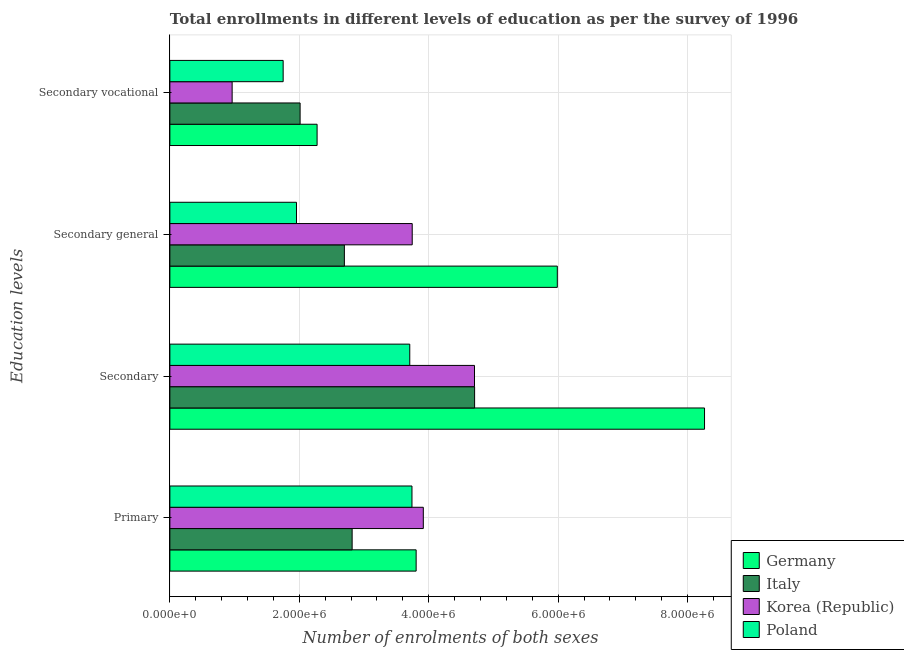How many groups of bars are there?
Make the answer very short. 4. Are the number of bars per tick equal to the number of legend labels?
Provide a succinct answer. Yes. Are the number of bars on each tick of the Y-axis equal?
Ensure brevity in your answer.  Yes. What is the label of the 3rd group of bars from the top?
Offer a very short reply. Secondary. What is the number of enrolments in secondary general education in Poland?
Your response must be concise. 1.96e+06. Across all countries, what is the maximum number of enrolments in secondary general education?
Give a very brief answer. 5.99e+06. Across all countries, what is the minimum number of enrolments in secondary general education?
Make the answer very short. 1.96e+06. In which country was the number of enrolments in secondary vocational education maximum?
Your response must be concise. Germany. What is the total number of enrolments in secondary vocational education in the graph?
Your answer should be very brief. 7.00e+06. What is the difference between the number of enrolments in secondary general education in Korea (Republic) and that in Poland?
Make the answer very short. 1.79e+06. What is the difference between the number of enrolments in primary education in Poland and the number of enrolments in secondary general education in Germany?
Provide a short and direct response. -2.25e+06. What is the average number of enrolments in secondary general education per country?
Offer a terse response. 3.60e+06. What is the difference between the number of enrolments in secondary education and number of enrolments in secondary vocational education in Poland?
Ensure brevity in your answer.  1.96e+06. What is the ratio of the number of enrolments in secondary general education in Korea (Republic) to that in Poland?
Provide a succinct answer. 1.91. Is the number of enrolments in primary education in Germany less than that in Poland?
Your answer should be compact. No. Is the difference between the number of enrolments in secondary general education in Korea (Republic) and Germany greater than the difference between the number of enrolments in secondary education in Korea (Republic) and Germany?
Offer a terse response. Yes. What is the difference between the highest and the second highest number of enrolments in secondary education?
Give a very brief answer. 3.55e+06. What is the difference between the highest and the lowest number of enrolments in secondary education?
Provide a short and direct response. 4.55e+06. In how many countries, is the number of enrolments in secondary education greater than the average number of enrolments in secondary education taken over all countries?
Offer a terse response. 1. Is the sum of the number of enrolments in primary education in Italy and Poland greater than the maximum number of enrolments in secondary vocational education across all countries?
Offer a terse response. Yes. What does the 1st bar from the top in Secondary general represents?
Give a very brief answer. Poland. What does the 4th bar from the bottom in Primary represents?
Offer a very short reply. Poland. Are the values on the major ticks of X-axis written in scientific E-notation?
Give a very brief answer. Yes. Does the graph contain any zero values?
Your answer should be compact. No. Where does the legend appear in the graph?
Provide a succinct answer. Bottom right. How many legend labels are there?
Provide a short and direct response. 4. How are the legend labels stacked?
Your answer should be compact. Vertical. What is the title of the graph?
Provide a short and direct response. Total enrollments in different levels of education as per the survey of 1996. Does "New Zealand" appear as one of the legend labels in the graph?
Make the answer very short. No. What is the label or title of the X-axis?
Make the answer very short. Number of enrolments of both sexes. What is the label or title of the Y-axis?
Give a very brief answer. Education levels. What is the Number of enrolments of both sexes in Germany in Primary?
Make the answer very short. 3.80e+06. What is the Number of enrolments of both sexes of Italy in Primary?
Give a very brief answer. 2.82e+06. What is the Number of enrolments of both sexes of Korea (Republic) in Primary?
Provide a succinct answer. 3.92e+06. What is the Number of enrolments of both sexes of Poland in Primary?
Offer a very short reply. 3.74e+06. What is the Number of enrolments of both sexes in Germany in Secondary?
Provide a short and direct response. 8.26e+06. What is the Number of enrolments of both sexes of Italy in Secondary?
Keep it short and to the point. 4.71e+06. What is the Number of enrolments of both sexes of Korea (Republic) in Secondary?
Ensure brevity in your answer.  4.71e+06. What is the Number of enrolments of both sexes of Poland in Secondary?
Your answer should be compact. 3.71e+06. What is the Number of enrolments of both sexes of Germany in Secondary general?
Your response must be concise. 5.99e+06. What is the Number of enrolments of both sexes of Italy in Secondary general?
Make the answer very short. 2.70e+06. What is the Number of enrolments of both sexes in Korea (Republic) in Secondary general?
Keep it short and to the point. 3.74e+06. What is the Number of enrolments of both sexes of Poland in Secondary general?
Your response must be concise. 1.96e+06. What is the Number of enrolments of both sexes in Germany in Secondary vocational?
Provide a succinct answer. 2.27e+06. What is the Number of enrolments of both sexes in Italy in Secondary vocational?
Provide a short and direct response. 2.01e+06. What is the Number of enrolments of both sexes in Korea (Republic) in Secondary vocational?
Offer a very short reply. 9.62e+05. What is the Number of enrolments of both sexes in Poland in Secondary vocational?
Offer a terse response. 1.75e+06. Across all Education levels, what is the maximum Number of enrolments of both sexes of Germany?
Your answer should be compact. 8.26e+06. Across all Education levels, what is the maximum Number of enrolments of both sexes of Italy?
Provide a succinct answer. 4.71e+06. Across all Education levels, what is the maximum Number of enrolments of both sexes in Korea (Republic)?
Your answer should be very brief. 4.71e+06. Across all Education levels, what is the maximum Number of enrolments of both sexes of Poland?
Ensure brevity in your answer.  3.74e+06. Across all Education levels, what is the minimum Number of enrolments of both sexes of Germany?
Provide a succinct answer. 2.27e+06. Across all Education levels, what is the minimum Number of enrolments of both sexes of Italy?
Your answer should be compact. 2.01e+06. Across all Education levels, what is the minimum Number of enrolments of both sexes in Korea (Republic)?
Ensure brevity in your answer.  9.62e+05. Across all Education levels, what is the minimum Number of enrolments of both sexes of Poland?
Give a very brief answer. 1.75e+06. What is the total Number of enrolments of both sexes in Germany in the graph?
Offer a terse response. 2.03e+07. What is the total Number of enrolments of both sexes of Italy in the graph?
Give a very brief answer. 1.22e+07. What is the total Number of enrolments of both sexes in Korea (Republic) in the graph?
Provide a succinct answer. 1.33e+07. What is the total Number of enrolments of both sexes of Poland in the graph?
Keep it short and to the point. 1.12e+07. What is the difference between the Number of enrolments of both sexes of Germany in Primary and that in Secondary?
Provide a succinct answer. -4.46e+06. What is the difference between the Number of enrolments of both sexes of Italy in Primary and that in Secondary?
Give a very brief answer. -1.89e+06. What is the difference between the Number of enrolments of both sexes in Korea (Republic) in Primary and that in Secondary?
Keep it short and to the point. -7.91e+05. What is the difference between the Number of enrolments of both sexes of Poland in Primary and that in Secondary?
Your response must be concise. 3.39e+04. What is the difference between the Number of enrolments of both sexes of Germany in Primary and that in Secondary general?
Your answer should be compact. -2.18e+06. What is the difference between the Number of enrolments of both sexes in Italy in Primary and that in Secondary general?
Keep it short and to the point. 1.20e+05. What is the difference between the Number of enrolments of both sexes of Korea (Republic) in Primary and that in Secondary general?
Offer a terse response. 1.71e+05. What is the difference between the Number of enrolments of both sexes of Poland in Primary and that in Secondary general?
Offer a very short reply. 1.78e+06. What is the difference between the Number of enrolments of both sexes of Germany in Primary and that in Secondary vocational?
Give a very brief answer. 1.53e+06. What is the difference between the Number of enrolments of both sexes in Italy in Primary and that in Secondary vocational?
Offer a very short reply. 8.04e+05. What is the difference between the Number of enrolments of both sexes of Korea (Republic) in Primary and that in Secondary vocational?
Ensure brevity in your answer.  2.95e+06. What is the difference between the Number of enrolments of both sexes in Poland in Primary and that in Secondary vocational?
Provide a short and direct response. 1.99e+06. What is the difference between the Number of enrolments of both sexes of Germany in Secondary and that in Secondary general?
Your answer should be compact. 2.27e+06. What is the difference between the Number of enrolments of both sexes in Italy in Secondary and that in Secondary general?
Keep it short and to the point. 2.01e+06. What is the difference between the Number of enrolments of both sexes of Korea (Republic) in Secondary and that in Secondary general?
Ensure brevity in your answer.  9.62e+05. What is the difference between the Number of enrolments of both sexes in Poland in Secondary and that in Secondary general?
Offer a very short reply. 1.75e+06. What is the difference between the Number of enrolments of both sexes in Germany in Secondary and that in Secondary vocational?
Keep it short and to the point. 5.99e+06. What is the difference between the Number of enrolments of both sexes in Italy in Secondary and that in Secondary vocational?
Offer a terse response. 2.70e+06. What is the difference between the Number of enrolments of both sexes of Korea (Republic) in Secondary and that in Secondary vocational?
Make the answer very short. 3.74e+06. What is the difference between the Number of enrolments of both sexes of Poland in Secondary and that in Secondary vocational?
Offer a very short reply. 1.96e+06. What is the difference between the Number of enrolments of both sexes in Germany in Secondary general and that in Secondary vocational?
Your answer should be compact. 3.71e+06. What is the difference between the Number of enrolments of both sexes in Italy in Secondary general and that in Secondary vocational?
Make the answer very short. 6.84e+05. What is the difference between the Number of enrolments of both sexes of Korea (Republic) in Secondary general and that in Secondary vocational?
Your answer should be very brief. 2.78e+06. What is the difference between the Number of enrolments of both sexes of Poland in Secondary general and that in Secondary vocational?
Keep it short and to the point. 2.06e+05. What is the difference between the Number of enrolments of both sexes in Germany in Primary and the Number of enrolments of both sexes in Italy in Secondary?
Make the answer very short. -9.04e+05. What is the difference between the Number of enrolments of both sexes of Germany in Primary and the Number of enrolments of both sexes of Korea (Republic) in Secondary?
Provide a succinct answer. -9.02e+05. What is the difference between the Number of enrolments of both sexes of Germany in Primary and the Number of enrolments of both sexes of Poland in Secondary?
Your answer should be very brief. 9.84e+04. What is the difference between the Number of enrolments of both sexes in Italy in Primary and the Number of enrolments of both sexes in Korea (Republic) in Secondary?
Your answer should be very brief. -1.89e+06. What is the difference between the Number of enrolments of both sexes in Italy in Primary and the Number of enrolments of both sexes in Poland in Secondary?
Keep it short and to the point. -8.90e+05. What is the difference between the Number of enrolments of both sexes of Korea (Republic) in Primary and the Number of enrolments of both sexes of Poland in Secondary?
Make the answer very short. 2.09e+05. What is the difference between the Number of enrolments of both sexes of Germany in Primary and the Number of enrolments of both sexes of Italy in Secondary general?
Keep it short and to the point. 1.11e+06. What is the difference between the Number of enrolments of both sexes in Germany in Primary and the Number of enrolments of both sexes in Korea (Republic) in Secondary general?
Provide a short and direct response. 6.04e+04. What is the difference between the Number of enrolments of both sexes of Germany in Primary and the Number of enrolments of both sexes of Poland in Secondary general?
Ensure brevity in your answer.  1.85e+06. What is the difference between the Number of enrolments of both sexes in Italy in Primary and the Number of enrolments of both sexes in Korea (Republic) in Secondary general?
Your answer should be compact. -9.28e+05. What is the difference between the Number of enrolments of both sexes in Italy in Primary and the Number of enrolments of both sexes in Poland in Secondary general?
Your answer should be compact. 8.60e+05. What is the difference between the Number of enrolments of both sexes of Korea (Republic) in Primary and the Number of enrolments of both sexes of Poland in Secondary general?
Provide a succinct answer. 1.96e+06. What is the difference between the Number of enrolments of both sexes in Germany in Primary and the Number of enrolments of both sexes in Italy in Secondary vocational?
Offer a terse response. 1.79e+06. What is the difference between the Number of enrolments of both sexes in Germany in Primary and the Number of enrolments of both sexes in Korea (Republic) in Secondary vocational?
Make the answer very short. 2.84e+06. What is the difference between the Number of enrolments of both sexes in Germany in Primary and the Number of enrolments of both sexes in Poland in Secondary vocational?
Your answer should be very brief. 2.05e+06. What is the difference between the Number of enrolments of both sexes of Italy in Primary and the Number of enrolments of both sexes of Korea (Republic) in Secondary vocational?
Provide a succinct answer. 1.85e+06. What is the difference between the Number of enrolments of both sexes in Italy in Primary and the Number of enrolments of both sexes in Poland in Secondary vocational?
Your response must be concise. 1.07e+06. What is the difference between the Number of enrolments of both sexes of Korea (Republic) in Primary and the Number of enrolments of both sexes of Poland in Secondary vocational?
Offer a very short reply. 2.17e+06. What is the difference between the Number of enrolments of both sexes of Germany in Secondary and the Number of enrolments of both sexes of Italy in Secondary general?
Give a very brief answer. 5.56e+06. What is the difference between the Number of enrolments of both sexes in Germany in Secondary and the Number of enrolments of both sexes in Korea (Republic) in Secondary general?
Keep it short and to the point. 4.52e+06. What is the difference between the Number of enrolments of both sexes in Germany in Secondary and the Number of enrolments of both sexes in Poland in Secondary general?
Your answer should be very brief. 6.30e+06. What is the difference between the Number of enrolments of both sexes of Italy in Secondary and the Number of enrolments of both sexes of Korea (Republic) in Secondary general?
Your answer should be compact. 9.64e+05. What is the difference between the Number of enrolments of both sexes in Italy in Secondary and the Number of enrolments of both sexes in Poland in Secondary general?
Provide a succinct answer. 2.75e+06. What is the difference between the Number of enrolments of both sexes in Korea (Republic) in Secondary and the Number of enrolments of both sexes in Poland in Secondary general?
Your response must be concise. 2.75e+06. What is the difference between the Number of enrolments of both sexes in Germany in Secondary and the Number of enrolments of both sexes in Italy in Secondary vocational?
Ensure brevity in your answer.  6.25e+06. What is the difference between the Number of enrolments of both sexes of Germany in Secondary and the Number of enrolments of both sexes of Korea (Republic) in Secondary vocational?
Keep it short and to the point. 7.30e+06. What is the difference between the Number of enrolments of both sexes of Germany in Secondary and the Number of enrolments of both sexes of Poland in Secondary vocational?
Provide a short and direct response. 6.51e+06. What is the difference between the Number of enrolments of both sexes of Italy in Secondary and the Number of enrolments of both sexes of Korea (Republic) in Secondary vocational?
Give a very brief answer. 3.75e+06. What is the difference between the Number of enrolments of both sexes of Italy in Secondary and the Number of enrolments of both sexes of Poland in Secondary vocational?
Your response must be concise. 2.96e+06. What is the difference between the Number of enrolments of both sexes of Korea (Republic) in Secondary and the Number of enrolments of both sexes of Poland in Secondary vocational?
Give a very brief answer. 2.96e+06. What is the difference between the Number of enrolments of both sexes in Germany in Secondary general and the Number of enrolments of both sexes in Italy in Secondary vocational?
Give a very brief answer. 3.97e+06. What is the difference between the Number of enrolments of both sexes of Germany in Secondary general and the Number of enrolments of both sexes of Korea (Republic) in Secondary vocational?
Keep it short and to the point. 5.02e+06. What is the difference between the Number of enrolments of both sexes of Germany in Secondary general and the Number of enrolments of both sexes of Poland in Secondary vocational?
Make the answer very short. 4.24e+06. What is the difference between the Number of enrolments of both sexes in Italy in Secondary general and the Number of enrolments of both sexes in Korea (Republic) in Secondary vocational?
Your answer should be very brief. 1.73e+06. What is the difference between the Number of enrolments of both sexes in Italy in Secondary general and the Number of enrolments of both sexes in Poland in Secondary vocational?
Provide a short and direct response. 9.46e+05. What is the difference between the Number of enrolments of both sexes of Korea (Republic) in Secondary general and the Number of enrolments of both sexes of Poland in Secondary vocational?
Make the answer very short. 1.99e+06. What is the average Number of enrolments of both sexes of Germany per Education levels?
Offer a very short reply. 5.08e+06. What is the average Number of enrolments of both sexes of Italy per Education levels?
Offer a very short reply. 3.06e+06. What is the average Number of enrolments of both sexes in Korea (Republic) per Education levels?
Your response must be concise. 3.33e+06. What is the average Number of enrolments of both sexes of Poland per Education levels?
Your response must be concise. 2.79e+06. What is the difference between the Number of enrolments of both sexes of Germany and Number of enrolments of both sexes of Italy in Primary?
Offer a very short reply. 9.89e+05. What is the difference between the Number of enrolments of both sexes of Germany and Number of enrolments of both sexes of Korea (Republic) in Primary?
Your response must be concise. -1.11e+05. What is the difference between the Number of enrolments of both sexes of Germany and Number of enrolments of both sexes of Poland in Primary?
Ensure brevity in your answer.  6.45e+04. What is the difference between the Number of enrolments of both sexes of Italy and Number of enrolments of both sexes of Korea (Republic) in Primary?
Offer a very short reply. -1.10e+06. What is the difference between the Number of enrolments of both sexes in Italy and Number of enrolments of both sexes in Poland in Primary?
Provide a short and direct response. -9.24e+05. What is the difference between the Number of enrolments of both sexes of Korea (Republic) and Number of enrolments of both sexes of Poland in Primary?
Provide a succinct answer. 1.75e+05. What is the difference between the Number of enrolments of both sexes of Germany and Number of enrolments of both sexes of Italy in Secondary?
Your answer should be very brief. 3.55e+06. What is the difference between the Number of enrolments of both sexes of Germany and Number of enrolments of both sexes of Korea (Republic) in Secondary?
Offer a terse response. 3.55e+06. What is the difference between the Number of enrolments of both sexes of Germany and Number of enrolments of both sexes of Poland in Secondary?
Offer a very short reply. 4.55e+06. What is the difference between the Number of enrolments of both sexes in Italy and Number of enrolments of both sexes in Korea (Republic) in Secondary?
Offer a terse response. 1865. What is the difference between the Number of enrolments of both sexes in Italy and Number of enrolments of both sexes in Poland in Secondary?
Your answer should be very brief. 1.00e+06. What is the difference between the Number of enrolments of both sexes of Korea (Republic) and Number of enrolments of both sexes of Poland in Secondary?
Offer a terse response. 1.00e+06. What is the difference between the Number of enrolments of both sexes of Germany and Number of enrolments of both sexes of Italy in Secondary general?
Give a very brief answer. 3.29e+06. What is the difference between the Number of enrolments of both sexes in Germany and Number of enrolments of both sexes in Korea (Republic) in Secondary general?
Your answer should be very brief. 2.24e+06. What is the difference between the Number of enrolments of both sexes in Germany and Number of enrolments of both sexes in Poland in Secondary general?
Keep it short and to the point. 4.03e+06. What is the difference between the Number of enrolments of both sexes of Italy and Number of enrolments of both sexes of Korea (Republic) in Secondary general?
Your answer should be very brief. -1.05e+06. What is the difference between the Number of enrolments of both sexes of Italy and Number of enrolments of both sexes of Poland in Secondary general?
Your answer should be compact. 7.40e+05. What is the difference between the Number of enrolments of both sexes in Korea (Republic) and Number of enrolments of both sexes in Poland in Secondary general?
Ensure brevity in your answer.  1.79e+06. What is the difference between the Number of enrolments of both sexes in Germany and Number of enrolments of both sexes in Italy in Secondary vocational?
Ensure brevity in your answer.  2.62e+05. What is the difference between the Number of enrolments of both sexes of Germany and Number of enrolments of both sexes of Korea (Republic) in Secondary vocational?
Give a very brief answer. 1.31e+06. What is the difference between the Number of enrolments of both sexes in Germany and Number of enrolments of both sexes in Poland in Secondary vocational?
Ensure brevity in your answer.  5.24e+05. What is the difference between the Number of enrolments of both sexes in Italy and Number of enrolments of both sexes in Korea (Republic) in Secondary vocational?
Offer a very short reply. 1.05e+06. What is the difference between the Number of enrolments of both sexes of Italy and Number of enrolments of both sexes of Poland in Secondary vocational?
Ensure brevity in your answer.  2.62e+05. What is the difference between the Number of enrolments of both sexes of Korea (Republic) and Number of enrolments of both sexes of Poland in Secondary vocational?
Your answer should be very brief. -7.88e+05. What is the ratio of the Number of enrolments of both sexes of Germany in Primary to that in Secondary?
Your answer should be compact. 0.46. What is the ratio of the Number of enrolments of both sexes in Italy in Primary to that in Secondary?
Provide a short and direct response. 0.6. What is the ratio of the Number of enrolments of both sexes in Korea (Republic) in Primary to that in Secondary?
Ensure brevity in your answer.  0.83. What is the ratio of the Number of enrolments of both sexes in Poland in Primary to that in Secondary?
Offer a terse response. 1.01. What is the ratio of the Number of enrolments of both sexes of Germany in Primary to that in Secondary general?
Provide a succinct answer. 0.64. What is the ratio of the Number of enrolments of both sexes in Italy in Primary to that in Secondary general?
Keep it short and to the point. 1.04. What is the ratio of the Number of enrolments of both sexes in Korea (Republic) in Primary to that in Secondary general?
Keep it short and to the point. 1.05. What is the ratio of the Number of enrolments of both sexes in Poland in Primary to that in Secondary general?
Your response must be concise. 1.91. What is the ratio of the Number of enrolments of both sexes in Germany in Primary to that in Secondary vocational?
Provide a succinct answer. 1.67. What is the ratio of the Number of enrolments of both sexes of Italy in Primary to that in Secondary vocational?
Provide a succinct answer. 1.4. What is the ratio of the Number of enrolments of both sexes of Korea (Republic) in Primary to that in Secondary vocational?
Make the answer very short. 4.07. What is the ratio of the Number of enrolments of both sexes of Poland in Primary to that in Secondary vocational?
Provide a succinct answer. 2.14. What is the ratio of the Number of enrolments of both sexes in Germany in Secondary to that in Secondary general?
Your response must be concise. 1.38. What is the ratio of the Number of enrolments of both sexes in Italy in Secondary to that in Secondary general?
Make the answer very short. 1.75. What is the ratio of the Number of enrolments of both sexes of Korea (Republic) in Secondary to that in Secondary general?
Your answer should be very brief. 1.26. What is the ratio of the Number of enrolments of both sexes in Poland in Secondary to that in Secondary general?
Keep it short and to the point. 1.89. What is the ratio of the Number of enrolments of both sexes in Germany in Secondary to that in Secondary vocational?
Offer a terse response. 3.63. What is the ratio of the Number of enrolments of both sexes of Italy in Secondary to that in Secondary vocational?
Offer a very short reply. 2.34. What is the ratio of the Number of enrolments of both sexes of Korea (Republic) in Secondary to that in Secondary vocational?
Provide a succinct answer. 4.89. What is the ratio of the Number of enrolments of both sexes of Poland in Secondary to that in Secondary vocational?
Keep it short and to the point. 2.12. What is the ratio of the Number of enrolments of both sexes of Germany in Secondary general to that in Secondary vocational?
Offer a terse response. 2.63. What is the ratio of the Number of enrolments of both sexes of Italy in Secondary general to that in Secondary vocational?
Ensure brevity in your answer.  1.34. What is the ratio of the Number of enrolments of both sexes of Korea (Republic) in Secondary general to that in Secondary vocational?
Keep it short and to the point. 3.89. What is the ratio of the Number of enrolments of both sexes of Poland in Secondary general to that in Secondary vocational?
Your response must be concise. 1.12. What is the difference between the highest and the second highest Number of enrolments of both sexes of Germany?
Offer a very short reply. 2.27e+06. What is the difference between the highest and the second highest Number of enrolments of both sexes in Italy?
Offer a terse response. 1.89e+06. What is the difference between the highest and the second highest Number of enrolments of both sexes in Korea (Republic)?
Give a very brief answer. 7.91e+05. What is the difference between the highest and the second highest Number of enrolments of both sexes in Poland?
Your answer should be very brief. 3.39e+04. What is the difference between the highest and the lowest Number of enrolments of both sexes in Germany?
Provide a short and direct response. 5.99e+06. What is the difference between the highest and the lowest Number of enrolments of both sexes in Italy?
Make the answer very short. 2.70e+06. What is the difference between the highest and the lowest Number of enrolments of both sexes in Korea (Republic)?
Your answer should be compact. 3.74e+06. What is the difference between the highest and the lowest Number of enrolments of both sexes of Poland?
Give a very brief answer. 1.99e+06. 